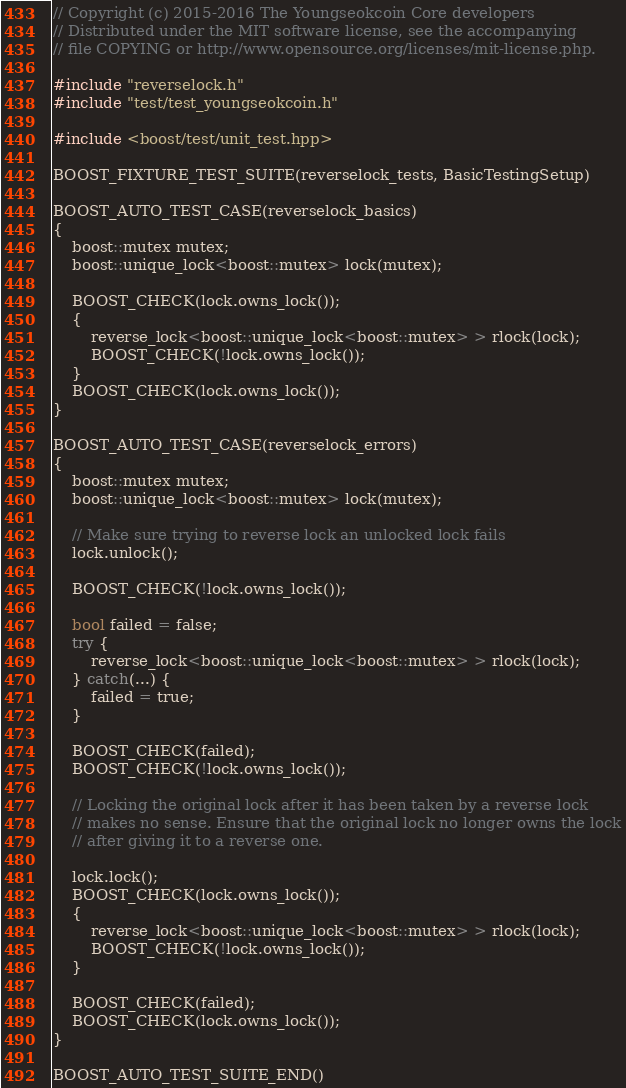<code> <loc_0><loc_0><loc_500><loc_500><_C++_>// Copyright (c) 2015-2016 The Youngseokcoin Core developers
// Distributed under the MIT software license, see the accompanying
// file COPYING or http://www.opensource.org/licenses/mit-license.php.

#include "reverselock.h"
#include "test/test_youngseokcoin.h"

#include <boost/test/unit_test.hpp>

BOOST_FIXTURE_TEST_SUITE(reverselock_tests, BasicTestingSetup)

BOOST_AUTO_TEST_CASE(reverselock_basics)
{
    boost::mutex mutex;
    boost::unique_lock<boost::mutex> lock(mutex);

    BOOST_CHECK(lock.owns_lock());
    {
        reverse_lock<boost::unique_lock<boost::mutex> > rlock(lock);
        BOOST_CHECK(!lock.owns_lock());
    }
    BOOST_CHECK(lock.owns_lock());
}

BOOST_AUTO_TEST_CASE(reverselock_errors)
{
    boost::mutex mutex;
    boost::unique_lock<boost::mutex> lock(mutex);

    // Make sure trying to reverse lock an unlocked lock fails
    lock.unlock();

    BOOST_CHECK(!lock.owns_lock());

    bool failed = false;
    try {
        reverse_lock<boost::unique_lock<boost::mutex> > rlock(lock);
    } catch(...) {
        failed = true;
    }

    BOOST_CHECK(failed);
    BOOST_CHECK(!lock.owns_lock());

    // Locking the original lock after it has been taken by a reverse lock
    // makes no sense. Ensure that the original lock no longer owns the lock
    // after giving it to a reverse one.

    lock.lock();
    BOOST_CHECK(lock.owns_lock());
    {
        reverse_lock<boost::unique_lock<boost::mutex> > rlock(lock);
        BOOST_CHECK(!lock.owns_lock());
    }

    BOOST_CHECK(failed);
    BOOST_CHECK(lock.owns_lock());
}

BOOST_AUTO_TEST_SUITE_END()
</code> 